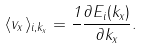Convert formula to latex. <formula><loc_0><loc_0><loc_500><loc_500>\langle v _ { x } \rangle _ { i , k _ { x } } = \frac { 1 } { } \frac { \partial E _ { i } ( k _ { x } ) } { \partial k _ { x } } .</formula> 